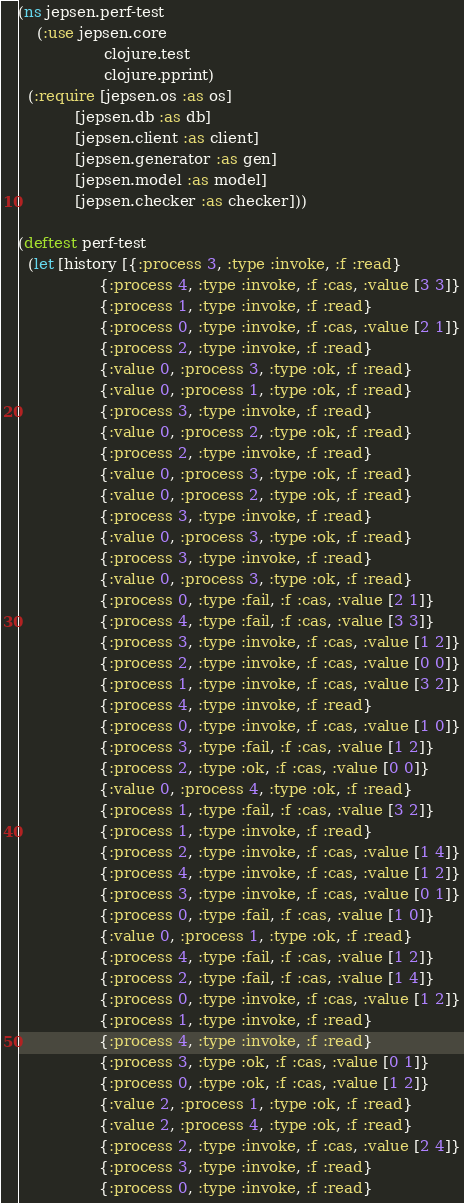Convert code to text. <code><loc_0><loc_0><loc_500><loc_500><_Clojure_>(ns jepsen.perf-test
    (:use jepsen.core
                  clojure.test
                  clojure.pprint)
  (:require [jepsen.os :as os]
            [jepsen.db :as db]
            [jepsen.client :as client]
            [jepsen.generator :as gen]
            [jepsen.model :as model]
            [jepsen.checker :as checker]))

(deftest perf-test
  (let [history [{:process 3, :type :invoke, :f :read}
                 {:process 4, :type :invoke, :f :cas, :value [3 3]}
                 {:process 1, :type :invoke, :f :read}
                 {:process 0, :type :invoke, :f :cas, :value [2 1]}
                 {:process 2, :type :invoke, :f :read}
                 {:value 0, :process 3, :type :ok, :f :read}
                 {:value 0, :process 1, :type :ok, :f :read}
                 {:process 3, :type :invoke, :f :read}
                 {:value 0, :process 2, :type :ok, :f :read}
                 {:process 2, :type :invoke, :f :read}
                 {:value 0, :process 3, :type :ok, :f :read}
                 {:value 0, :process 2, :type :ok, :f :read}
                 {:process 3, :type :invoke, :f :read}
                 {:value 0, :process 3, :type :ok, :f :read}
                 {:process 3, :type :invoke, :f :read}
                 {:value 0, :process 3, :type :ok, :f :read}
                 {:process 0, :type :fail, :f :cas, :value [2 1]}
                 {:process 4, :type :fail, :f :cas, :value [3 3]}
                 {:process 3, :type :invoke, :f :cas, :value [1 2]}
                 {:process 2, :type :invoke, :f :cas, :value [0 0]}
                 {:process 1, :type :invoke, :f :cas, :value [3 2]}
                 {:process 4, :type :invoke, :f :read}
                 {:process 0, :type :invoke, :f :cas, :value [1 0]}
                 {:process 3, :type :fail, :f :cas, :value [1 2]}
                 {:process 2, :type :ok, :f :cas, :value [0 0]}
                 {:value 0, :process 4, :type :ok, :f :read}
                 {:process 1, :type :fail, :f :cas, :value [3 2]}
                 {:process 1, :type :invoke, :f :read}
                 {:process 2, :type :invoke, :f :cas, :value [1 4]}
                 {:process 4, :type :invoke, :f :cas, :value [1 2]}
                 {:process 3, :type :invoke, :f :cas, :value [0 1]}
                 {:process 0, :type :fail, :f :cas, :value [1 0]}
                 {:value 0, :process 1, :type :ok, :f :read}
                 {:process 4, :type :fail, :f :cas, :value [1 2]}
                 {:process 2, :type :fail, :f :cas, :value [1 4]}
                 {:process 0, :type :invoke, :f :cas, :value [1 2]}
                 {:process 1, :type :invoke, :f :read}
                 {:process 4, :type :invoke, :f :read}
                 {:process 3, :type :ok, :f :cas, :value [0 1]}
                 {:process 0, :type :ok, :f :cas, :value [1 2]}
                 {:value 2, :process 1, :type :ok, :f :read}
                 {:value 2, :process 4, :type :ok, :f :read}
                 {:process 2, :type :invoke, :f :cas, :value [2 4]}
                 {:process 3, :type :invoke, :f :read}
                 {:process 0, :type :invoke, :f :read}</code> 